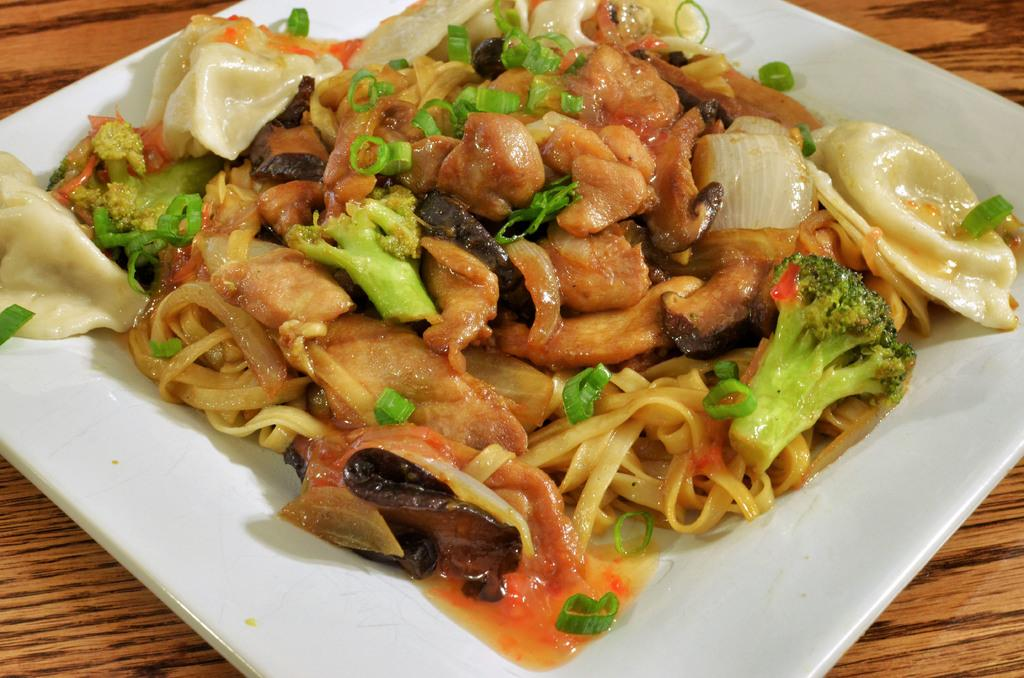What type of vegetables can be seen in the image? There are pieces of broccoli and spring onions in the image. What type of noodles are in the image? There are noodles in the image. Are there any other vegetables present in the image? Yes, there are onions in the image. What is the color of the plate that holds the food items? The food items are on a white plate. What is the surface beneath the white plate? The white plate is on a wooden surface. What sound does the tiger make in the image? There is no tiger present in the image, so it is not possible to determine the sound it might make. 